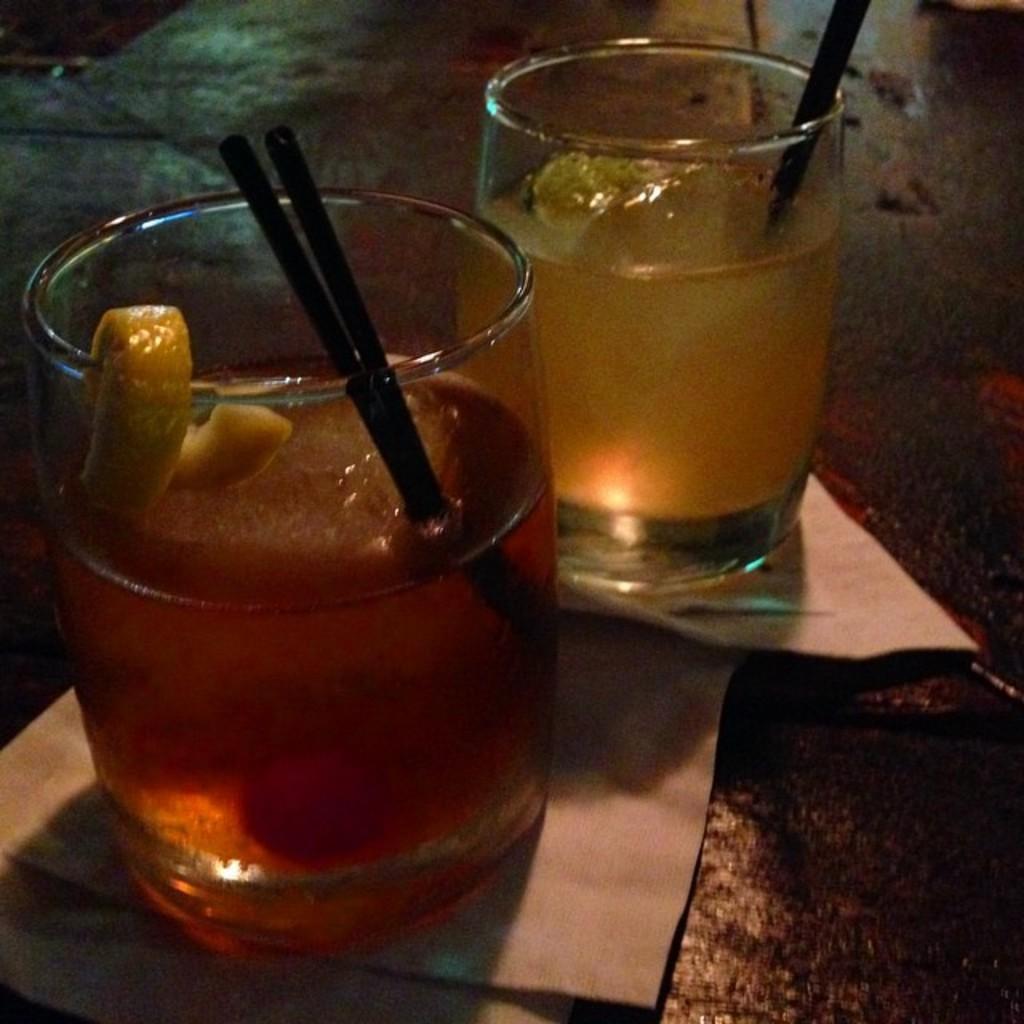How would you summarize this image in a sentence or two? There are two glasses on papers. Inside the glass there is a liquid, straws and a piece of lemon. 